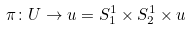<formula> <loc_0><loc_0><loc_500><loc_500>\pi \colon U \to u = S ^ { 1 } _ { 1 } \times S ^ { 1 } _ { 2 } \times u</formula> 